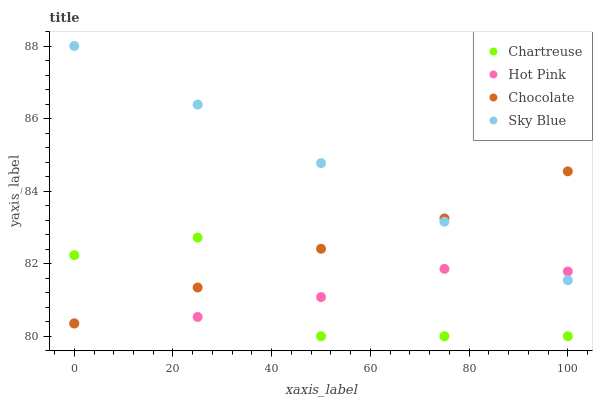Does Chartreuse have the minimum area under the curve?
Answer yes or no. Yes. Does Sky Blue have the maximum area under the curve?
Answer yes or no. Yes. Does Hot Pink have the minimum area under the curve?
Answer yes or no. No. Does Hot Pink have the maximum area under the curve?
Answer yes or no. No. Is Sky Blue the smoothest?
Answer yes or no. Yes. Is Chartreuse the roughest?
Answer yes or no. Yes. Is Hot Pink the smoothest?
Answer yes or no. No. Is Hot Pink the roughest?
Answer yes or no. No. Does Chartreuse have the lowest value?
Answer yes or no. Yes. Does Hot Pink have the lowest value?
Answer yes or no. No. Does Sky Blue have the highest value?
Answer yes or no. Yes. Does Chartreuse have the highest value?
Answer yes or no. No. Is Chartreuse less than Sky Blue?
Answer yes or no. Yes. Is Sky Blue greater than Chartreuse?
Answer yes or no. Yes. Does Chocolate intersect Chartreuse?
Answer yes or no. Yes. Is Chocolate less than Chartreuse?
Answer yes or no. No. Is Chocolate greater than Chartreuse?
Answer yes or no. No. Does Chartreuse intersect Sky Blue?
Answer yes or no. No. 